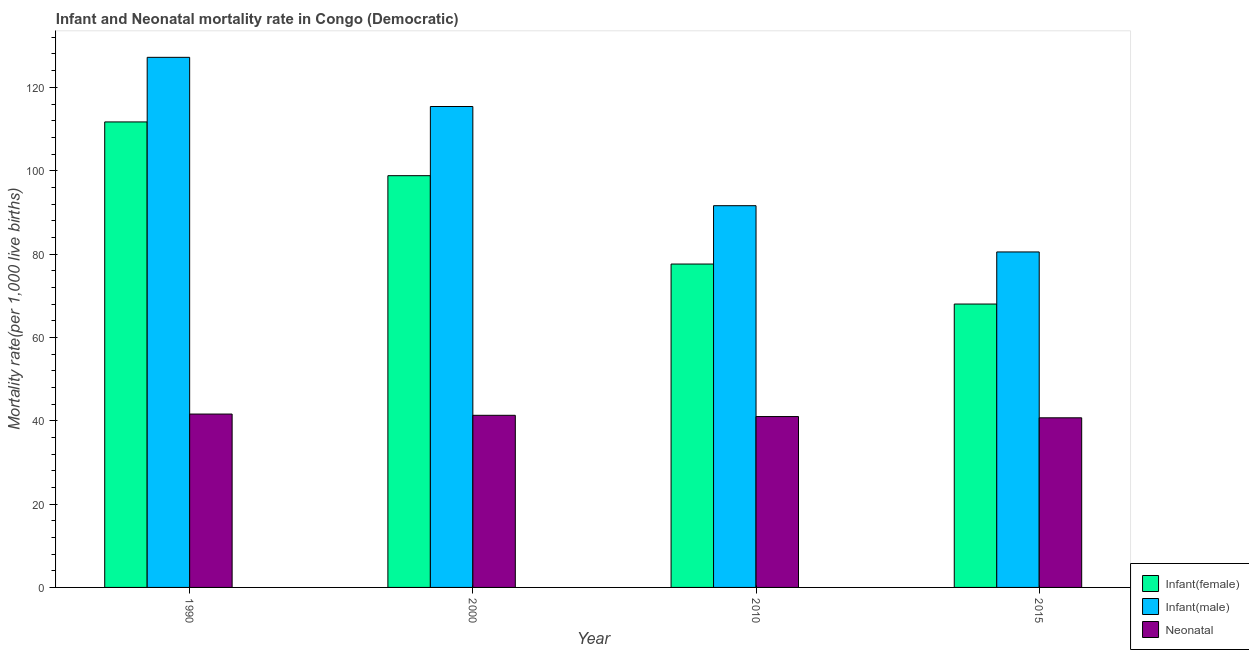How many bars are there on the 1st tick from the left?
Offer a terse response. 3. In how many cases, is the number of bars for a given year not equal to the number of legend labels?
Keep it short and to the point. 0. What is the infant mortality rate(female) in 2010?
Make the answer very short. 77.6. Across all years, what is the maximum infant mortality rate(female)?
Provide a succinct answer. 111.7. Across all years, what is the minimum infant mortality rate(female)?
Give a very brief answer. 68. In which year was the neonatal mortality rate maximum?
Provide a succinct answer. 1990. In which year was the infant mortality rate(female) minimum?
Offer a terse response. 2015. What is the total neonatal mortality rate in the graph?
Offer a very short reply. 164.6. What is the difference between the neonatal mortality rate in 1990 and that in 2015?
Provide a short and direct response. 0.9. What is the difference between the infant mortality rate(female) in 2000 and the neonatal mortality rate in 2015?
Offer a very short reply. 30.8. What is the average infant mortality rate(male) per year?
Your answer should be compact. 103.68. What is the ratio of the infant mortality rate(female) in 1990 to that in 2000?
Make the answer very short. 1.13. Is the infant mortality rate(female) in 1990 less than that in 2000?
Your response must be concise. No. Is the difference between the infant mortality rate(female) in 1990 and 2000 greater than the difference between the infant mortality rate(male) in 1990 and 2000?
Offer a terse response. No. What is the difference between the highest and the second highest neonatal mortality rate?
Make the answer very short. 0.3. What is the difference between the highest and the lowest infant mortality rate(male)?
Ensure brevity in your answer.  46.7. In how many years, is the neonatal mortality rate greater than the average neonatal mortality rate taken over all years?
Provide a short and direct response. 2. Is the sum of the infant mortality rate(male) in 2010 and 2015 greater than the maximum neonatal mortality rate across all years?
Make the answer very short. Yes. What does the 2nd bar from the left in 1990 represents?
Your answer should be compact. Infant(male). What does the 2nd bar from the right in 2015 represents?
Make the answer very short. Infant(male). How many bars are there?
Ensure brevity in your answer.  12. What is the difference between two consecutive major ticks on the Y-axis?
Ensure brevity in your answer.  20. Are the values on the major ticks of Y-axis written in scientific E-notation?
Offer a terse response. No. Does the graph contain grids?
Offer a very short reply. No. How many legend labels are there?
Give a very brief answer. 3. What is the title of the graph?
Offer a terse response. Infant and Neonatal mortality rate in Congo (Democratic). What is the label or title of the Y-axis?
Give a very brief answer. Mortality rate(per 1,0 live births). What is the Mortality rate(per 1,000 live births) of Infant(female) in 1990?
Your answer should be very brief. 111.7. What is the Mortality rate(per 1,000 live births) of Infant(male) in 1990?
Your answer should be very brief. 127.2. What is the Mortality rate(per 1,000 live births) in Neonatal  in 1990?
Ensure brevity in your answer.  41.6. What is the Mortality rate(per 1,000 live births) of Infant(female) in 2000?
Ensure brevity in your answer.  98.8. What is the Mortality rate(per 1,000 live births) of Infant(male) in 2000?
Give a very brief answer. 115.4. What is the Mortality rate(per 1,000 live births) of Neonatal  in 2000?
Give a very brief answer. 41.3. What is the Mortality rate(per 1,000 live births) in Infant(female) in 2010?
Keep it short and to the point. 77.6. What is the Mortality rate(per 1,000 live births) in Infant(male) in 2010?
Your answer should be very brief. 91.6. What is the Mortality rate(per 1,000 live births) in Infant(male) in 2015?
Offer a very short reply. 80.5. What is the Mortality rate(per 1,000 live births) in Neonatal  in 2015?
Offer a terse response. 40.7. Across all years, what is the maximum Mortality rate(per 1,000 live births) of Infant(female)?
Make the answer very short. 111.7. Across all years, what is the maximum Mortality rate(per 1,000 live births) of Infant(male)?
Keep it short and to the point. 127.2. Across all years, what is the maximum Mortality rate(per 1,000 live births) of Neonatal ?
Your response must be concise. 41.6. Across all years, what is the minimum Mortality rate(per 1,000 live births) of Infant(female)?
Offer a very short reply. 68. Across all years, what is the minimum Mortality rate(per 1,000 live births) in Infant(male)?
Make the answer very short. 80.5. Across all years, what is the minimum Mortality rate(per 1,000 live births) of Neonatal ?
Ensure brevity in your answer.  40.7. What is the total Mortality rate(per 1,000 live births) of Infant(female) in the graph?
Make the answer very short. 356.1. What is the total Mortality rate(per 1,000 live births) of Infant(male) in the graph?
Provide a short and direct response. 414.7. What is the total Mortality rate(per 1,000 live births) of Neonatal  in the graph?
Offer a very short reply. 164.6. What is the difference between the Mortality rate(per 1,000 live births) in Infant(male) in 1990 and that in 2000?
Your answer should be very brief. 11.8. What is the difference between the Mortality rate(per 1,000 live births) in Infant(female) in 1990 and that in 2010?
Provide a succinct answer. 34.1. What is the difference between the Mortality rate(per 1,000 live births) of Infant(male) in 1990 and that in 2010?
Your response must be concise. 35.6. What is the difference between the Mortality rate(per 1,000 live births) of Infant(female) in 1990 and that in 2015?
Offer a terse response. 43.7. What is the difference between the Mortality rate(per 1,000 live births) of Infant(male) in 1990 and that in 2015?
Ensure brevity in your answer.  46.7. What is the difference between the Mortality rate(per 1,000 live births) in Neonatal  in 1990 and that in 2015?
Offer a very short reply. 0.9. What is the difference between the Mortality rate(per 1,000 live births) of Infant(female) in 2000 and that in 2010?
Your response must be concise. 21.2. What is the difference between the Mortality rate(per 1,000 live births) in Infant(male) in 2000 and that in 2010?
Offer a very short reply. 23.8. What is the difference between the Mortality rate(per 1,000 live births) in Infant(female) in 2000 and that in 2015?
Your answer should be compact. 30.8. What is the difference between the Mortality rate(per 1,000 live births) of Infant(male) in 2000 and that in 2015?
Offer a terse response. 34.9. What is the difference between the Mortality rate(per 1,000 live births) of Infant(female) in 1990 and the Mortality rate(per 1,000 live births) of Neonatal  in 2000?
Your response must be concise. 70.4. What is the difference between the Mortality rate(per 1,000 live births) in Infant(male) in 1990 and the Mortality rate(per 1,000 live births) in Neonatal  in 2000?
Provide a short and direct response. 85.9. What is the difference between the Mortality rate(per 1,000 live births) of Infant(female) in 1990 and the Mortality rate(per 1,000 live births) of Infant(male) in 2010?
Your response must be concise. 20.1. What is the difference between the Mortality rate(per 1,000 live births) in Infant(female) in 1990 and the Mortality rate(per 1,000 live births) in Neonatal  in 2010?
Keep it short and to the point. 70.7. What is the difference between the Mortality rate(per 1,000 live births) in Infant(male) in 1990 and the Mortality rate(per 1,000 live births) in Neonatal  in 2010?
Provide a succinct answer. 86.2. What is the difference between the Mortality rate(per 1,000 live births) in Infant(female) in 1990 and the Mortality rate(per 1,000 live births) in Infant(male) in 2015?
Offer a very short reply. 31.2. What is the difference between the Mortality rate(per 1,000 live births) of Infant(male) in 1990 and the Mortality rate(per 1,000 live births) of Neonatal  in 2015?
Your answer should be very brief. 86.5. What is the difference between the Mortality rate(per 1,000 live births) in Infant(female) in 2000 and the Mortality rate(per 1,000 live births) in Neonatal  in 2010?
Offer a terse response. 57.8. What is the difference between the Mortality rate(per 1,000 live births) of Infant(male) in 2000 and the Mortality rate(per 1,000 live births) of Neonatal  in 2010?
Your answer should be compact. 74.4. What is the difference between the Mortality rate(per 1,000 live births) of Infant(female) in 2000 and the Mortality rate(per 1,000 live births) of Infant(male) in 2015?
Offer a terse response. 18.3. What is the difference between the Mortality rate(per 1,000 live births) in Infant(female) in 2000 and the Mortality rate(per 1,000 live births) in Neonatal  in 2015?
Provide a succinct answer. 58.1. What is the difference between the Mortality rate(per 1,000 live births) in Infant(male) in 2000 and the Mortality rate(per 1,000 live births) in Neonatal  in 2015?
Offer a terse response. 74.7. What is the difference between the Mortality rate(per 1,000 live births) of Infant(female) in 2010 and the Mortality rate(per 1,000 live births) of Infant(male) in 2015?
Make the answer very short. -2.9. What is the difference between the Mortality rate(per 1,000 live births) in Infant(female) in 2010 and the Mortality rate(per 1,000 live births) in Neonatal  in 2015?
Ensure brevity in your answer.  36.9. What is the difference between the Mortality rate(per 1,000 live births) of Infant(male) in 2010 and the Mortality rate(per 1,000 live births) of Neonatal  in 2015?
Give a very brief answer. 50.9. What is the average Mortality rate(per 1,000 live births) in Infant(female) per year?
Your answer should be compact. 89.03. What is the average Mortality rate(per 1,000 live births) of Infant(male) per year?
Your response must be concise. 103.67. What is the average Mortality rate(per 1,000 live births) in Neonatal  per year?
Offer a very short reply. 41.15. In the year 1990, what is the difference between the Mortality rate(per 1,000 live births) of Infant(female) and Mortality rate(per 1,000 live births) of Infant(male)?
Your answer should be compact. -15.5. In the year 1990, what is the difference between the Mortality rate(per 1,000 live births) in Infant(female) and Mortality rate(per 1,000 live births) in Neonatal ?
Provide a succinct answer. 70.1. In the year 1990, what is the difference between the Mortality rate(per 1,000 live births) in Infant(male) and Mortality rate(per 1,000 live births) in Neonatal ?
Keep it short and to the point. 85.6. In the year 2000, what is the difference between the Mortality rate(per 1,000 live births) of Infant(female) and Mortality rate(per 1,000 live births) of Infant(male)?
Provide a succinct answer. -16.6. In the year 2000, what is the difference between the Mortality rate(per 1,000 live births) in Infant(female) and Mortality rate(per 1,000 live births) in Neonatal ?
Offer a terse response. 57.5. In the year 2000, what is the difference between the Mortality rate(per 1,000 live births) of Infant(male) and Mortality rate(per 1,000 live births) of Neonatal ?
Ensure brevity in your answer.  74.1. In the year 2010, what is the difference between the Mortality rate(per 1,000 live births) of Infant(female) and Mortality rate(per 1,000 live births) of Neonatal ?
Keep it short and to the point. 36.6. In the year 2010, what is the difference between the Mortality rate(per 1,000 live births) in Infant(male) and Mortality rate(per 1,000 live births) in Neonatal ?
Give a very brief answer. 50.6. In the year 2015, what is the difference between the Mortality rate(per 1,000 live births) of Infant(female) and Mortality rate(per 1,000 live births) of Infant(male)?
Provide a short and direct response. -12.5. In the year 2015, what is the difference between the Mortality rate(per 1,000 live births) in Infant(female) and Mortality rate(per 1,000 live births) in Neonatal ?
Offer a very short reply. 27.3. In the year 2015, what is the difference between the Mortality rate(per 1,000 live births) of Infant(male) and Mortality rate(per 1,000 live births) of Neonatal ?
Your response must be concise. 39.8. What is the ratio of the Mortality rate(per 1,000 live births) in Infant(female) in 1990 to that in 2000?
Your answer should be compact. 1.13. What is the ratio of the Mortality rate(per 1,000 live births) of Infant(male) in 1990 to that in 2000?
Give a very brief answer. 1.1. What is the ratio of the Mortality rate(per 1,000 live births) of Neonatal  in 1990 to that in 2000?
Keep it short and to the point. 1.01. What is the ratio of the Mortality rate(per 1,000 live births) of Infant(female) in 1990 to that in 2010?
Give a very brief answer. 1.44. What is the ratio of the Mortality rate(per 1,000 live births) of Infant(male) in 1990 to that in 2010?
Make the answer very short. 1.39. What is the ratio of the Mortality rate(per 1,000 live births) of Neonatal  in 1990 to that in 2010?
Offer a terse response. 1.01. What is the ratio of the Mortality rate(per 1,000 live births) in Infant(female) in 1990 to that in 2015?
Make the answer very short. 1.64. What is the ratio of the Mortality rate(per 1,000 live births) in Infant(male) in 1990 to that in 2015?
Give a very brief answer. 1.58. What is the ratio of the Mortality rate(per 1,000 live births) of Neonatal  in 1990 to that in 2015?
Make the answer very short. 1.02. What is the ratio of the Mortality rate(per 1,000 live births) in Infant(female) in 2000 to that in 2010?
Ensure brevity in your answer.  1.27. What is the ratio of the Mortality rate(per 1,000 live births) in Infant(male) in 2000 to that in 2010?
Make the answer very short. 1.26. What is the ratio of the Mortality rate(per 1,000 live births) in Neonatal  in 2000 to that in 2010?
Offer a very short reply. 1.01. What is the ratio of the Mortality rate(per 1,000 live births) of Infant(female) in 2000 to that in 2015?
Your answer should be compact. 1.45. What is the ratio of the Mortality rate(per 1,000 live births) of Infant(male) in 2000 to that in 2015?
Keep it short and to the point. 1.43. What is the ratio of the Mortality rate(per 1,000 live births) in Neonatal  in 2000 to that in 2015?
Provide a short and direct response. 1.01. What is the ratio of the Mortality rate(per 1,000 live births) in Infant(female) in 2010 to that in 2015?
Offer a terse response. 1.14. What is the ratio of the Mortality rate(per 1,000 live births) of Infant(male) in 2010 to that in 2015?
Your answer should be very brief. 1.14. What is the ratio of the Mortality rate(per 1,000 live births) in Neonatal  in 2010 to that in 2015?
Offer a terse response. 1.01. What is the difference between the highest and the second highest Mortality rate(per 1,000 live births) in Infant(female)?
Offer a very short reply. 12.9. What is the difference between the highest and the lowest Mortality rate(per 1,000 live births) of Infant(female)?
Give a very brief answer. 43.7. What is the difference between the highest and the lowest Mortality rate(per 1,000 live births) in Infant(male)?
Your response must be concise. 46.7. 